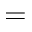<formula> <loc_0><loc_0><loc_500><loc_500>=</formula> 